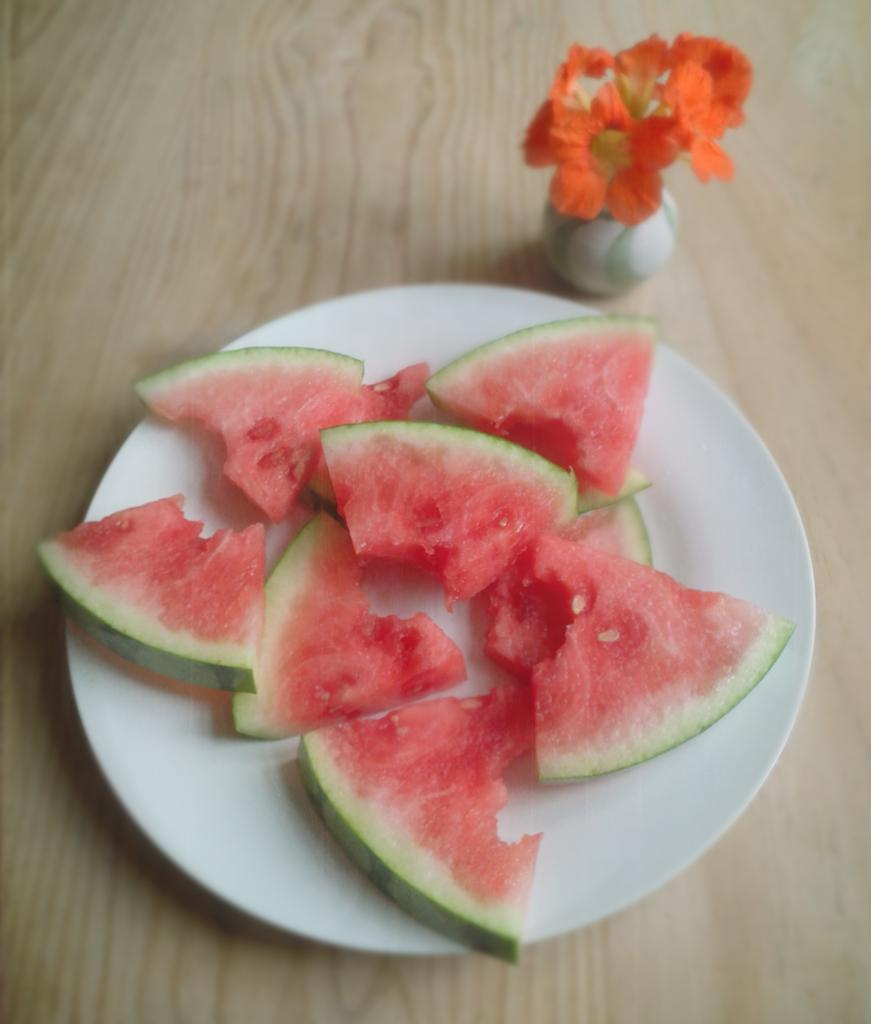What type of food is on the plate in the image? There are watermelon pieces on a plate in the image. What decorative item is present in the image? There are flowers in a vase in the image. Where are the plate and vase located in the image? The plate and vase are on a table in the image. How many times does the crow kiss the mother in the image? There is no crow or mother present in the image; it only features watermelon pieces on a plate and flowers in a vase on a table. 